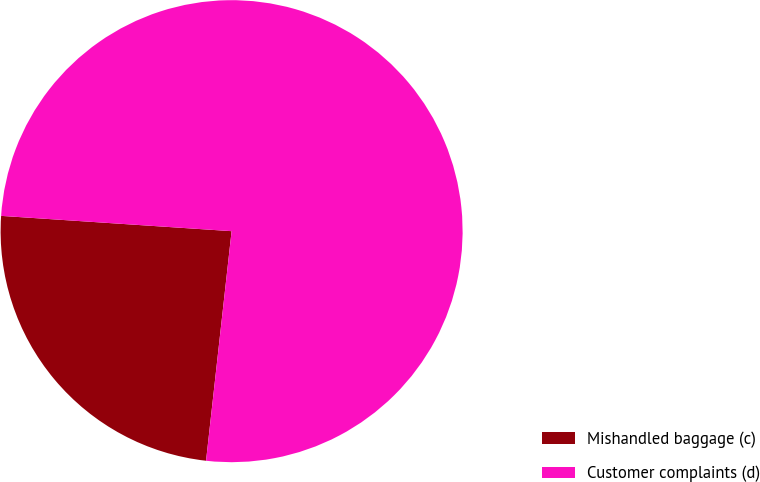Convert chart to OTSL. <chart><loc_0><loc_0><loc_500><loc_500><pie_chart><fcel>Mishandled baggage (c)<fcel>Customer complaints (d)<nl><fcel>24.29%<fcel>75.71%<nl></chart> 